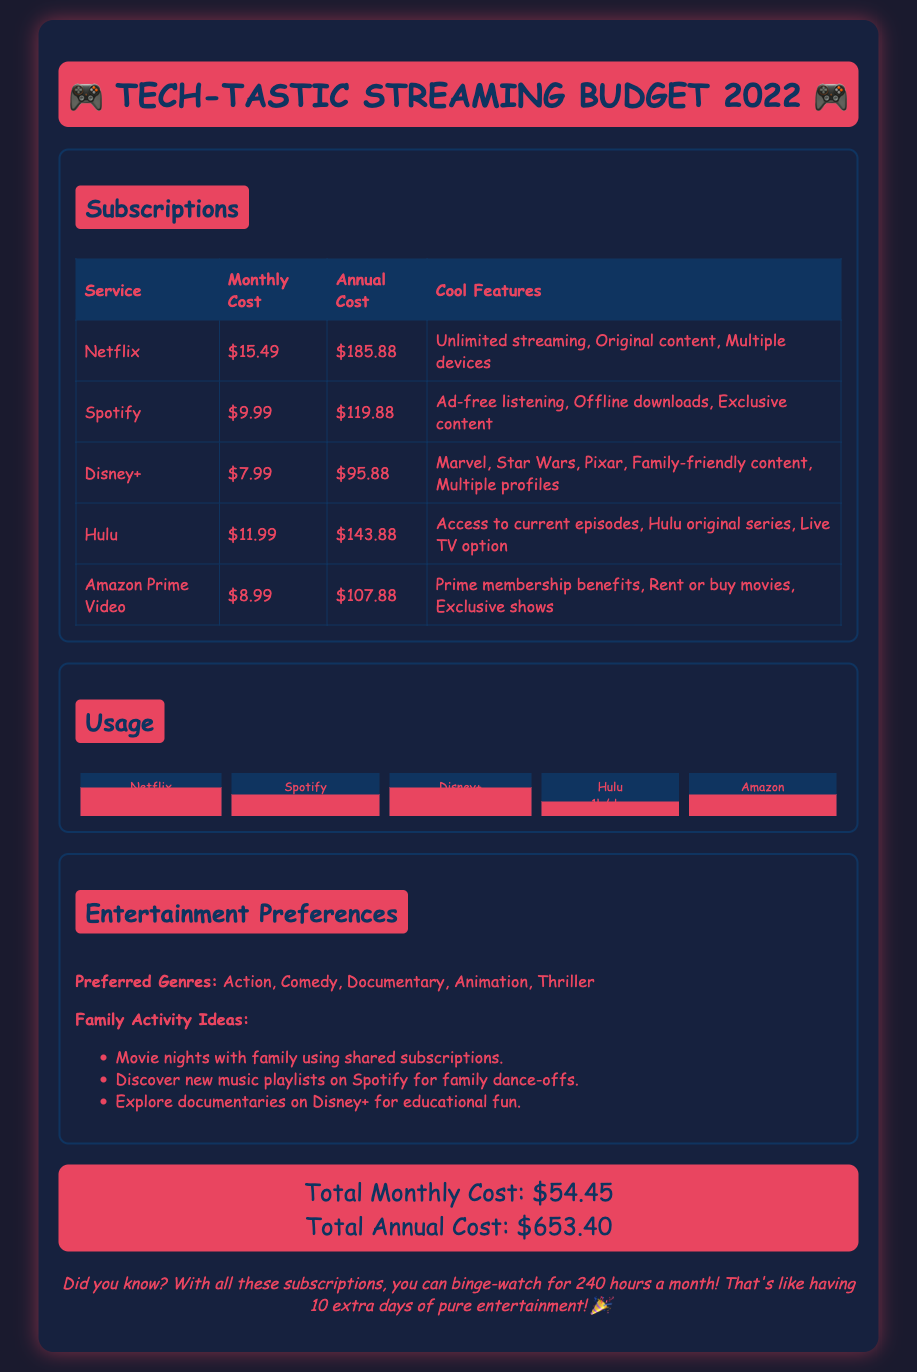What is the total monthly cost for streaming services? The total monthly cost is explicitly stated at the bottom of the document.
Answer: $54.45 What is the annual cost for Spotify? The annual cost can be found in the subscriptions table.
Answer: $119.88 How many hours per day is Netflix used? The usage information is provided in the usage section of the document.
Answer: 2h/day What subscription has the highest monthly cost? The subscription costs can be compared from the table in the document.
Answer: Netflix Which genre is listed as a preferred genre? The preferred genres are directly mentioned in the entertainment preferences section.
Answer: Action How many extra days of entertainment does the total monthly usage suggest? The fun fact provides insight into the total hours of entertainment calculated monthly.
Answer: 10 What are two cool features of Disney+? The features are listed in the subscriptions table for Disney+.
Answer: Marvel, Star Wars How many hours per day is Hulu used? The usage information is specified in the usage chart.
Answer: 1h/day What is the name of the document? This can be identified from the title in the document.
Answer: Tech-tastic Streaming Budget 2022 